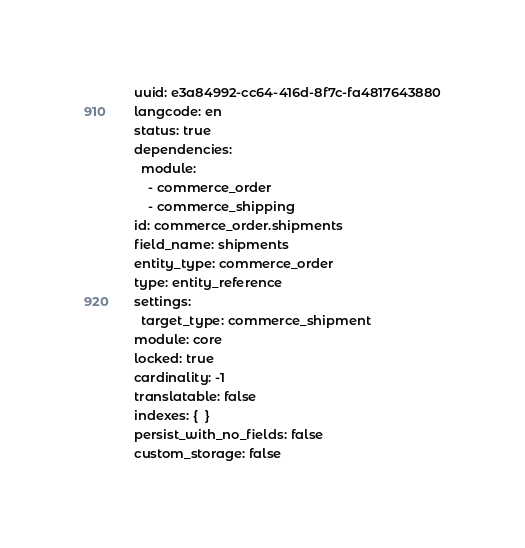<code> <loc_0><loc_0><loc_500><loc_500><_YAML_>uuid: e3a84992-cc64-416d-8f7c-fa4817643880
langcode: en
status: true
dependencies:
  module:
    - commerce_order
    - commerce_shipping
id: commerce_order.shipments
field_name: shipments
entity_type: commerce_order
type: entity_reference
settings:
  target_type: commerce_shipment
module: core
locked: true
cardinality: -1
translatable: false
indexes: {  }
persist_with_no_fields: false
custom_storage: false
</code> 